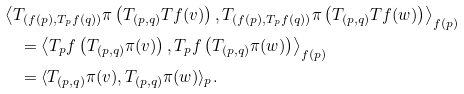<formula> <loc_0><loc_0><loc_500><loc_500>& \left \langle T _ { ( f ( p ) , T _ { p } f ( q ) ) } \pi \left ( T _ { ( p , q ) } T f ( v ) \right ) , T _ { ( f ( p ) , T _ { p } f ( q ) ) } \pi \left ( T _ { ( p , q ) } T f ( w ) \right ) \right \rangle _ { f ( p ) } \\ & \quad = \left \langle T _ { p } f \left ( T _ { ( p , q ) } \pi ( v ) \right ) , T _ { p } f \left ( T _ { ( p , q ) } \pi ( w ) \right ) \right \rangle _ { f ( p ) } \\ & \quad = \langle T _ { ( p , q ) } \pi ( v ) , T _ { ( p , q ) } \pi ( w ) \rangle _ { p } .</formula> 